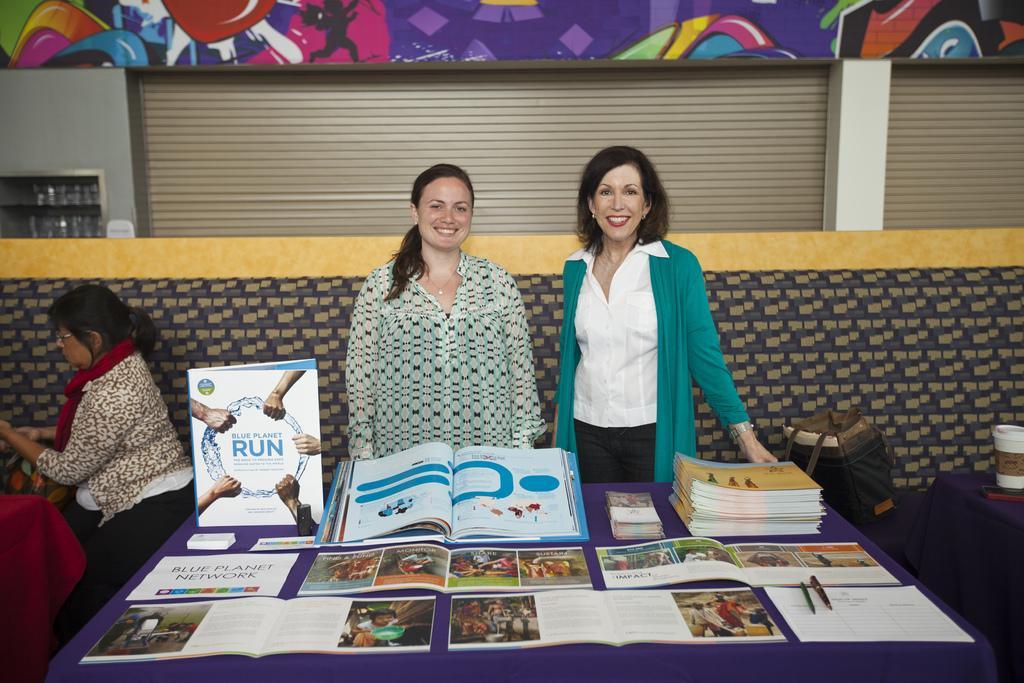Could you give a brief overview of what you see in this image? In this picture, there are two woman standing beside the table. On the table there are books and papers. A woman towards the left, she is wearing a white and black top. Beside her, there is another woman wearing green shirt and a white shirt. Towards the left, there is another woman wearing brown and white top with a red scarf. In the background there are shutters with paintings. 